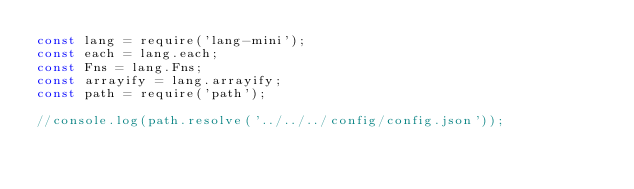<code> <loc_0><loc_0><loc_500><loc_500><_JavaScript_>const lang = require('lang-mini');
const each = lang.each;
const Fns = lang.Fns;
const arrayify = lang.arrayify;
const path = require('path');

//console.log(path.resolve('../../../config/config.json'));
</code> 